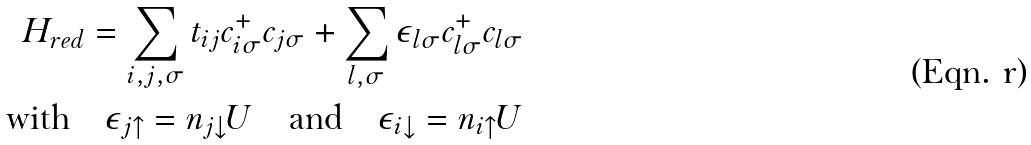<formula> <loc_0><loc_0><loc_500><loc_500>H _ { r e d } = \sum _ { i , j , \sigma } t _ { i j } c ^ { + } _ { i \sigma } c _ { j \sigma } + \sum _ { l , \sigma } \epsilon _ { l \sigma } c ^ { + } _ { l \sigma } c _ { l \sigma } \\ \text {with} \quad \epsilon _ { j \uparrow } = n _ { j \downarrow } U \quad \text {and} \quad \epsilon _ { i \downarrow } = n _ { i \uparrow } U</formula> 